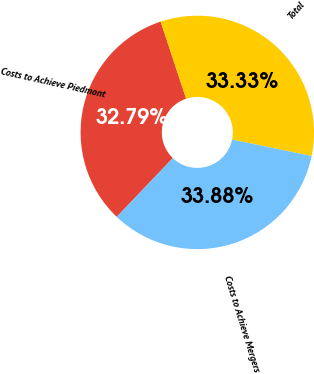Convert chart. <chart><loc_0><loc_0><loc_500><loc_500><pie_chart><fcel>Costs to Achieve Piedmont<fcel>Total<fcel>Costs to Achieve Mergers<nl><fcel>32.79%<fcel>33.33%<fcel>33.88%<nl></chart> 